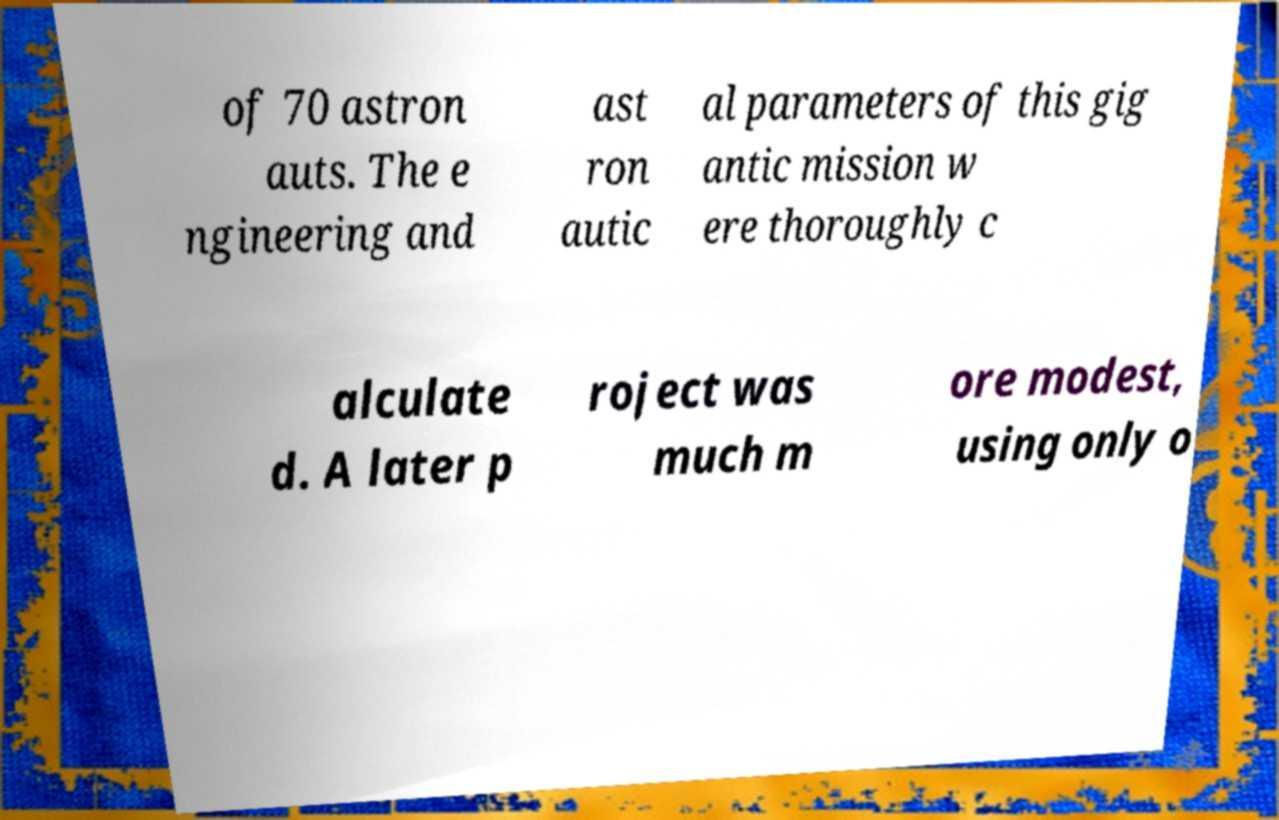Please read and relay the text visible in this image. What does it say? of 70 astron auts. The e ngineering and ast ron autic al parameters of this gig antic mission w ere thoroughly c alculate d. A later p roject was much m ore modest, using only o 